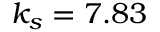Convert formula to latex. <formula><loc_0><loc_0><loc_500><loc_500>k _ { s } = 7 . 8 3</formula> 